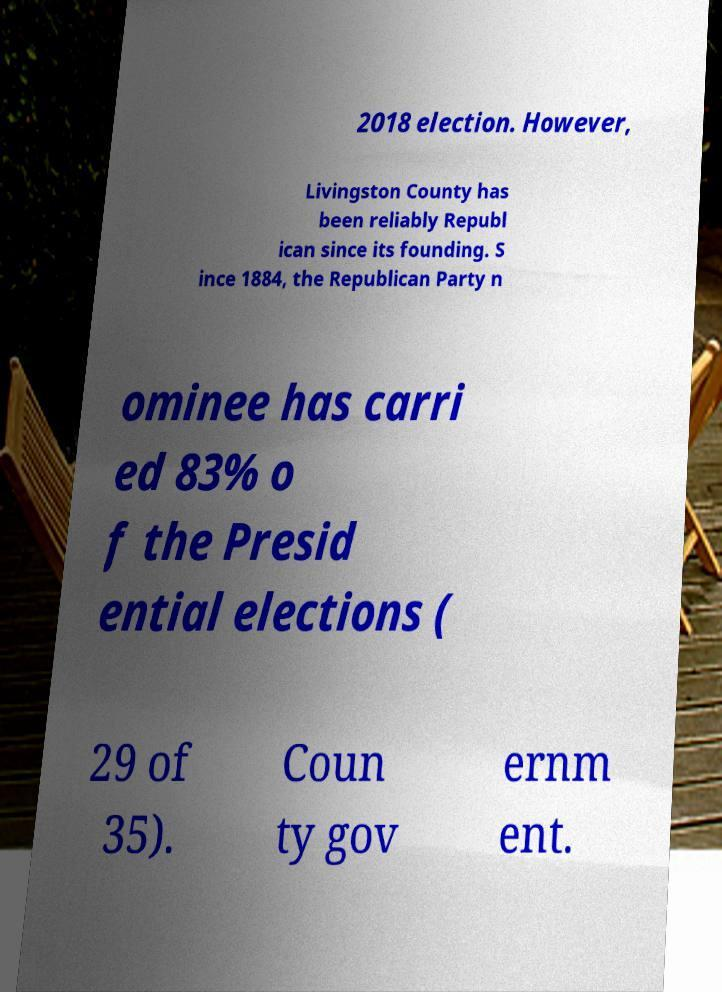Can you read and provide the text displayed in the image?This photo seems to have some interesting text. Can you extract and type it out for me? 2018 election. However, Livingston County has been reliably Republ ican since its founding. S ince 1884, the Republican Party n ominee has carri ed 83% o f the Presid ential elections ( 29 of 35). Coun ty gov ernm ent. 